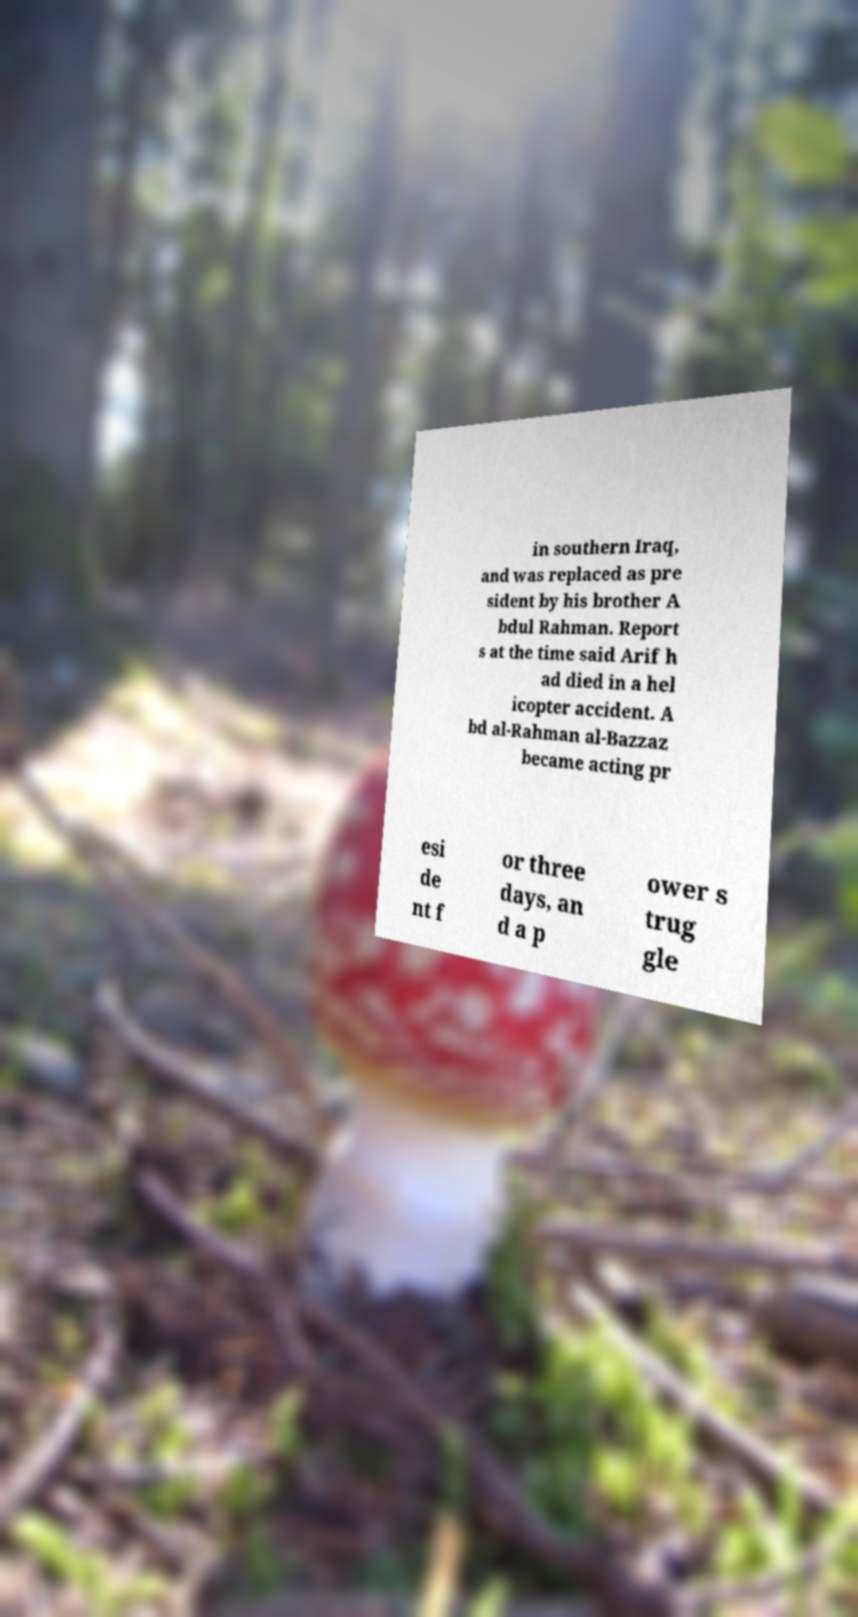There's text embedded in this image that I need extracted. Can you transcribe it verbatim? in southern Iraq, and was replaced as pre sident by his brother A bdul Rahman. Report s at the time said Arif h ad died in a hel icopter accident. A bd al-Rahman al-Bazzaz became acting pr esi de nt f or three days, an d a p ower s trug gle 